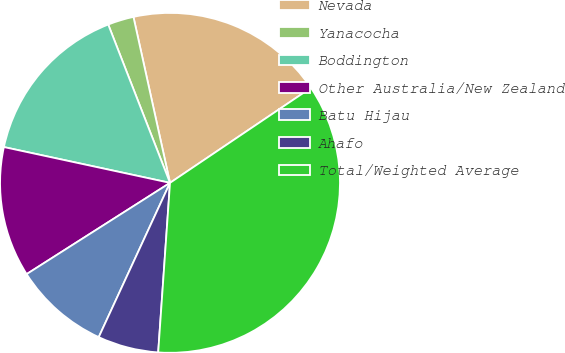<chart> <loc_0><loc_0><loc_500><loc_500><pie_chart><fcel>Nevada<fcel>Yanacocha<fcel>Boddington<fcel>Other Australia/New Zealand<fcel>Batu Hijau<fcel>Ahafo<fcel>Total/Weighted Average<nl><fcel>19.01%<fcel>2.47%<fcel>15.7%<fcel>12.4%<fcel>9.09%<fcel>5.78%<fcel>35.55%<nl></chart> 